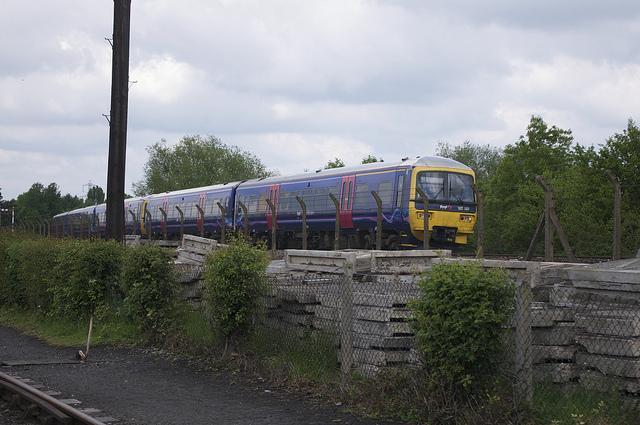How many people are on the motorcycle?
Give a very brief answer. 0. 